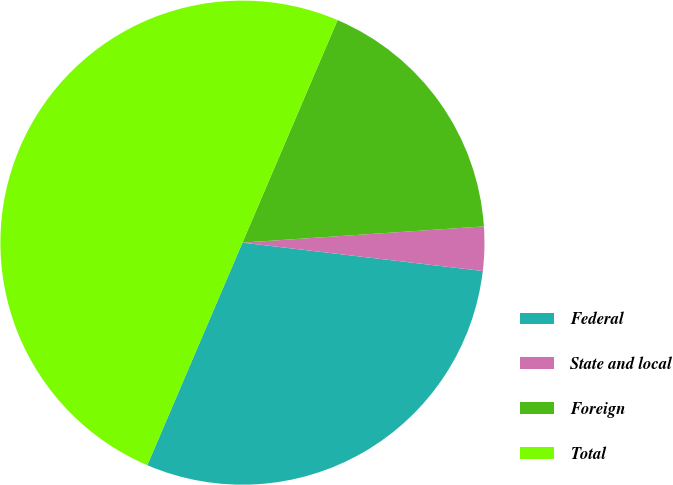<chart> <loc_0><loc_0><loc_500><loc_500><pie_chart><fcel>Federal<fcel>State and local<fcel>Foreign<fcel>Total<nl><fcel>29.56%<fcel>2.94%<fcel>17.5%<fcel>50.0%<nl></chart> 